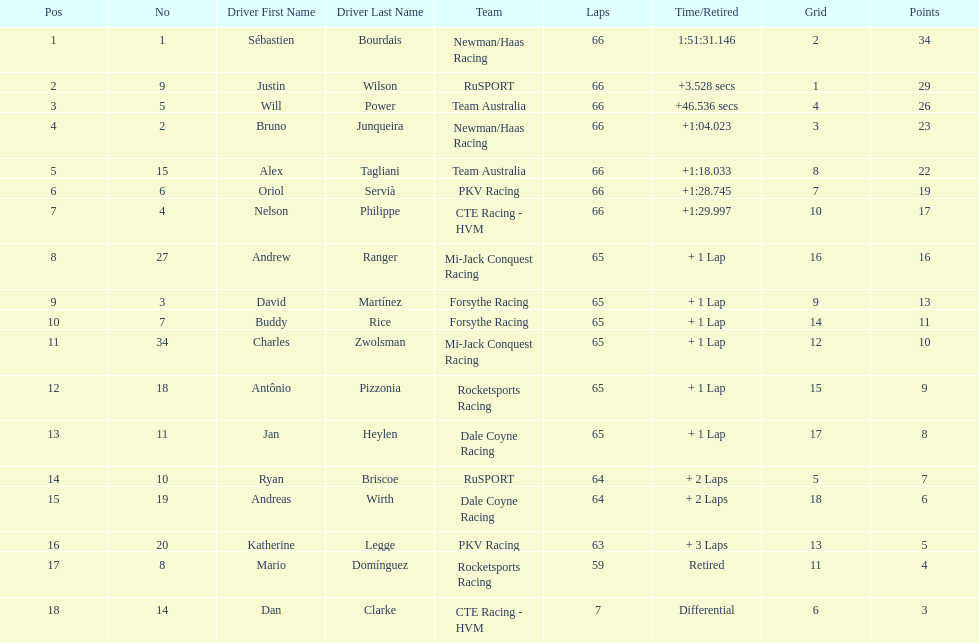How many drivers did not make more than 60 laps? 2. 